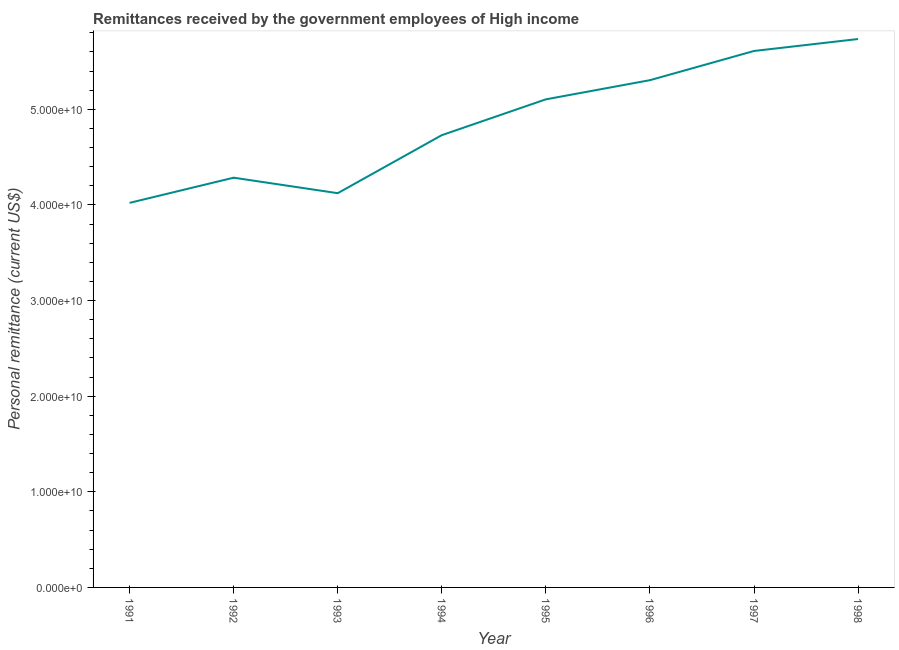What is the personal remittances in 1997?
Provide a succinct answer. 5.61e+1. Across all years, what is the maximum personal remittances?
Make the answer very short. 5.74e+1. Across all years, what is the minimum personal remittances?
Offer a terse response. 4.02e+1. In which year was the personal remittances maximum?
Keep it short and to the point. 1998. In which year was the personal remittances minimum?
Make the answer very short. 1991. What is the sum of the personal remittances?
Provide a short and direct response. 3.89e+11. What is the difference between the personal remittances in 1991 and 1998?
Provide a succinct answer. -1.71e+1. What is the average personal remittances per year?
Make the answer very short. 4.86e+1. What is the median personal remittances?
Your response must be concise. 4.92e+1. Do a majority of the years between 1995 and 1996 (inclusive) have personal remittances greater than 40000000000 US$?
Your response must be concise. Yes. What is the ratio of the personal remittances in 1993 to that in 1995?
Provide a short and direct response. 0.81. Is the difference between the personal remittances in 1992 and 1995 greater than the difference between any two years?
Offer a very short reply. No. What is the difference between the highest and the second highest personal remittances?
Offer a very short reply. 1.25e+09. What is the difference between the highest and the lowest personal remittances?
Provide a succinct answer. 1.71e+1. How many lines are there?
Provide a short and direct response. 1. Are the values on the major ticks of Y-axis written in scientific E-notation?
Offer a very short reply. Yes. Does the graph contain any zero values?
Offer a terse response. No. What is the title of the graph?
Offer a terse response. Remittances received by the government employees of High income. What is the label or title of the Y-axis?
Ensure brevity in your answer.  Personal remittance (current US$). What is the Personal remittance (current US$) of 1991?
Your response must be concise. 4.02e+1. What is the Personal remittance (current US$) in 1992?
Your answer should be compact. 4.28e+1. What is the Personal remittance (current US$) in 1993?
Ensure brevity in your answer.  4.12e+1. What is the Personal remittance (current US$) of 1994?
Make the answer very short. 4.73e+1. What is the Personal remittance (current US$) of 1995?
Offer a terse response. 5.10e+1. What is the Personal remittance (current US$) in 1996?
Provide a short and direct response. 5.30e+1. What is the Personal remittance (current US$) in 1997?
Your answer should be very brief. 5.61e+1. What is the Personal remittance (current US$) of 1998?
Provide a succinct answer. 5.74e+1. What is the difference between the Personal remittance (current US$) in 1991 and 1992?
Your response must be concise. -2.63e+09. What is the difference between the Personal remittance (current US$) in 1991 and 1993?
Offer a terse response. -1.01e+09. What is the difference between the Personal remittance (current US$) in 1991 and 1994?
Offer a very short reply. -7.08e+09. What is the difference between the Personal remittance (current US$) in 1991 and 1995?
Offer a terse response. -1.08e+1. What is the difference between the Personal remittance (current US$) in 1991 and 1996?
Offer a very short reply. -1.28e+1. What is the difference between the Personal remittance (current US$) in 1991 and 1997?
Keep it short and to the point. -1.59e+1. What is the difference between the Personal remittance (current US$) in 1991 and 1998?
Provide a short and direct response. -1.71e+1. What is the difference between the Personal remittance (current US$) in 1992 and 1993?
Provide a succinct answer. 1.62e+09. What is the difference between the Personal remittance (current US$) in 1992 and 1994?
Keep it short and to the point. -4.45e+09. What is the difference between the Personal remittance (current US$) in 1992 and 1995?
Provide a short and direct response. -8.20e+09. What is the difference between the Personal remittance (current US$) in 1992 and 1996?
Your response must be concise. -1.02e+1. What is the difference between the Personal remittance (current US$) in 1992 and 1997?
Provide a succinct answer. -1.33e+1. What is the difference between the Personal remittance (current US$) in 1992 and 1998?
Your response must be concise. -1.45e+1. What is the difference between the Personal remittance (current US$) in 1993 and 1994?
Give a very brief answer. -6.07e+09. What is the difference between the Personal remittance (current US$) in 1993 and 1995?
Ensure brevity in your answer.  -9.81e+09. What is the difference between the Personal remittance (current US$) in 1993 and 1996?
Offer a terse response. -1.18e+1. What is the difference between the Personal remittance (current US$) in 1993 and 1997?
Your response must be concise. -1.49e+1. What is the difference between the Personal remittance (current US$) in 1993 and 1998?
Ensure brevity in your answer.  -1.61e+1. What is the difference between the Personal remittance (current US$) in 1994 and 1995?
Provide a short and direct response. -3.75e+09. What is the difference between the Personal remittance (current US$) in 1994 and 1996?
Your response must be concise. -5.75e+09. What is the difference between the Personal remittance (current US$) in 1994 and 1997?
Provide a succinct answer. -8.80e+09. What is the difference between the Personal remittance (current US$) in 1994 and 1998?
Keep it short and to the point. -1.01e+1. What is the difference between the Personal remittance (current US$) in 1995 and 1996?
Your response must be concise. -2.00e+09. What is the difference between the Personal remittance (current US$) in 1995 and 1997?
Make the answer very short. -5.06e+09. What is the difference between the Personal remittance (current US$) in 1995 and 1998?
Your response must be concise. -6.31e+09. What is the difference between the Personal remittance (current US$) in 1996 and 1997?
Offer a very short reply. -3.05e+09. What is the difference between the Personal remittance (current US$) in 1996 and 1998?
Provide a succinct answer. -4.30e+09. What is the difference between the Personal remittance (current US$) in 1997 and 1998?
Provide a short and direct response. -1.25e+09. What is the ratio of the Personal remittance (current US$) in 1991 to that in 1992?
Offer a very short reply. 0.94. What is the ratio of the Personal remittance (current US$) in 1991 to that in 1995?
Offer a terse response. 0.79. What is the ratio of the Personal remittance (current US$) in 1991 to that in 1996?
Your answer should be compact. 0.76. What is the ratio of the Personal remittance (current US$) in 1991 to that in 1997?
Keep it short and to the point. 0.72. What is the ratio of the Personal remittance (current US$) in 1991 to that in 1998?
Make the answer very short. 0.7. What is the ratio of the Personal remittance (current US$) in 1992 to that in 1993?
Ensure brevity in your answer.  1.04. What is the ratio of the Personal remittance (current US$) in 1992 to that in 1994?
Give a very brief answer. 0.91. What is the ratio of the Personal remittance (current US$) in 1992 to that in 1995?
Offer a very short reply. 0.84. What is the ratio of the Personal remittance (current US$) in 1992 to that in 1996?
Your answer should be compact. 0.81. What is the ratio of the Personal remittance (current US$) in 1992 to that in 1997?
Offer a very short reply. 0.76. What is the ratio of the Personal remittance (current US$) in 1992 to that in 1998?
Keep it short and to the point. 0.75. What is the ratio of the Personal remittance (current US$) in 1993 to that in 1994?
Your answer should be very brief. 0.87. What is the ratio of the Personal remittance (current US$) in 1993 to that in 1995?
Your answer should be compact. 0.81. What is the ratio of the Personal remittance (current US$) in 1993 to that in 1996?
Provide a succinct answer. 0.78. What is the ratio of the Personal remittance (current US$) in 1993 to that in 1997?
Offer a terse response. 0.73. What is the ratio of the Personal remittance (current US$) in 1993 to that in 1998?
Make the answer very short. 0.72. What is the ratio of the Personal remittance (current US$) in 1994 to that in 1995?
Keep it short and to the point. 0.93. What is the ratio of the Personal remittance (current US$) in 1994 to that in 1996?
Your answer should be very brief. 0.89. What is the ratio of the Personal remittance (current US$) in 1994 to that in 1997?
Offer a terse response. 0.84. What is the ratio of the Personal remittance (current US$) in 1994 to that in 1998?
Ensure brevity in your answer.  0.82. What is the ratio of the Personal remittance (current US$) in 1995 to that in 1996?
Keep it short and to the point. 0.96. What is the ratio of the Personal remittance (current US$) in 1995 to that in 1997?
Your response must be concise. 0.91. What is the ratio of the Personal remittance (current US$) in 1995 to that in 1998?
Provide a succinct answer. 0.89. What is the ratio of the Personal remittance (current US$) in 1996 to that in 1997?
Your response must be concise. 0.95. What is the ratio of the Personal remittance (current US$) in 1996 to that in 1998?
Your answer should be compact. 0.93. What is the ratio of the Personal remittance (current US$) in 1997 to that in 1998?
Provide a short and direct response. 0.98. 